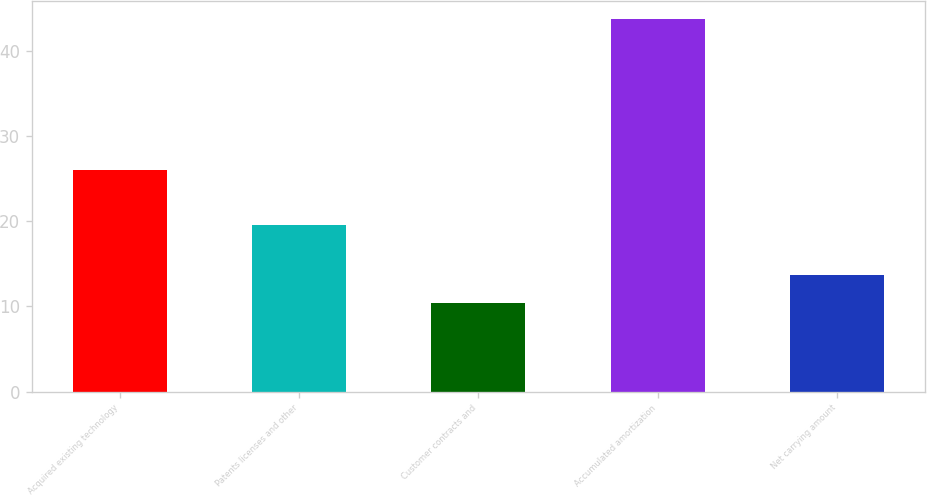Convert chart. <chart><loc_0><loc_0><loc_500><loc_500><bar_chart><fcel>Acquired existing technology<fcel>Patents licenses and other<fcel>Customer contracts and<fcel>Accumulated amortization<fcel>Net carrying amount<nl><fcel>26<fcel>19.6<fcel>10.4<fcel>43.7<fcel>13.73<nl></chart> 